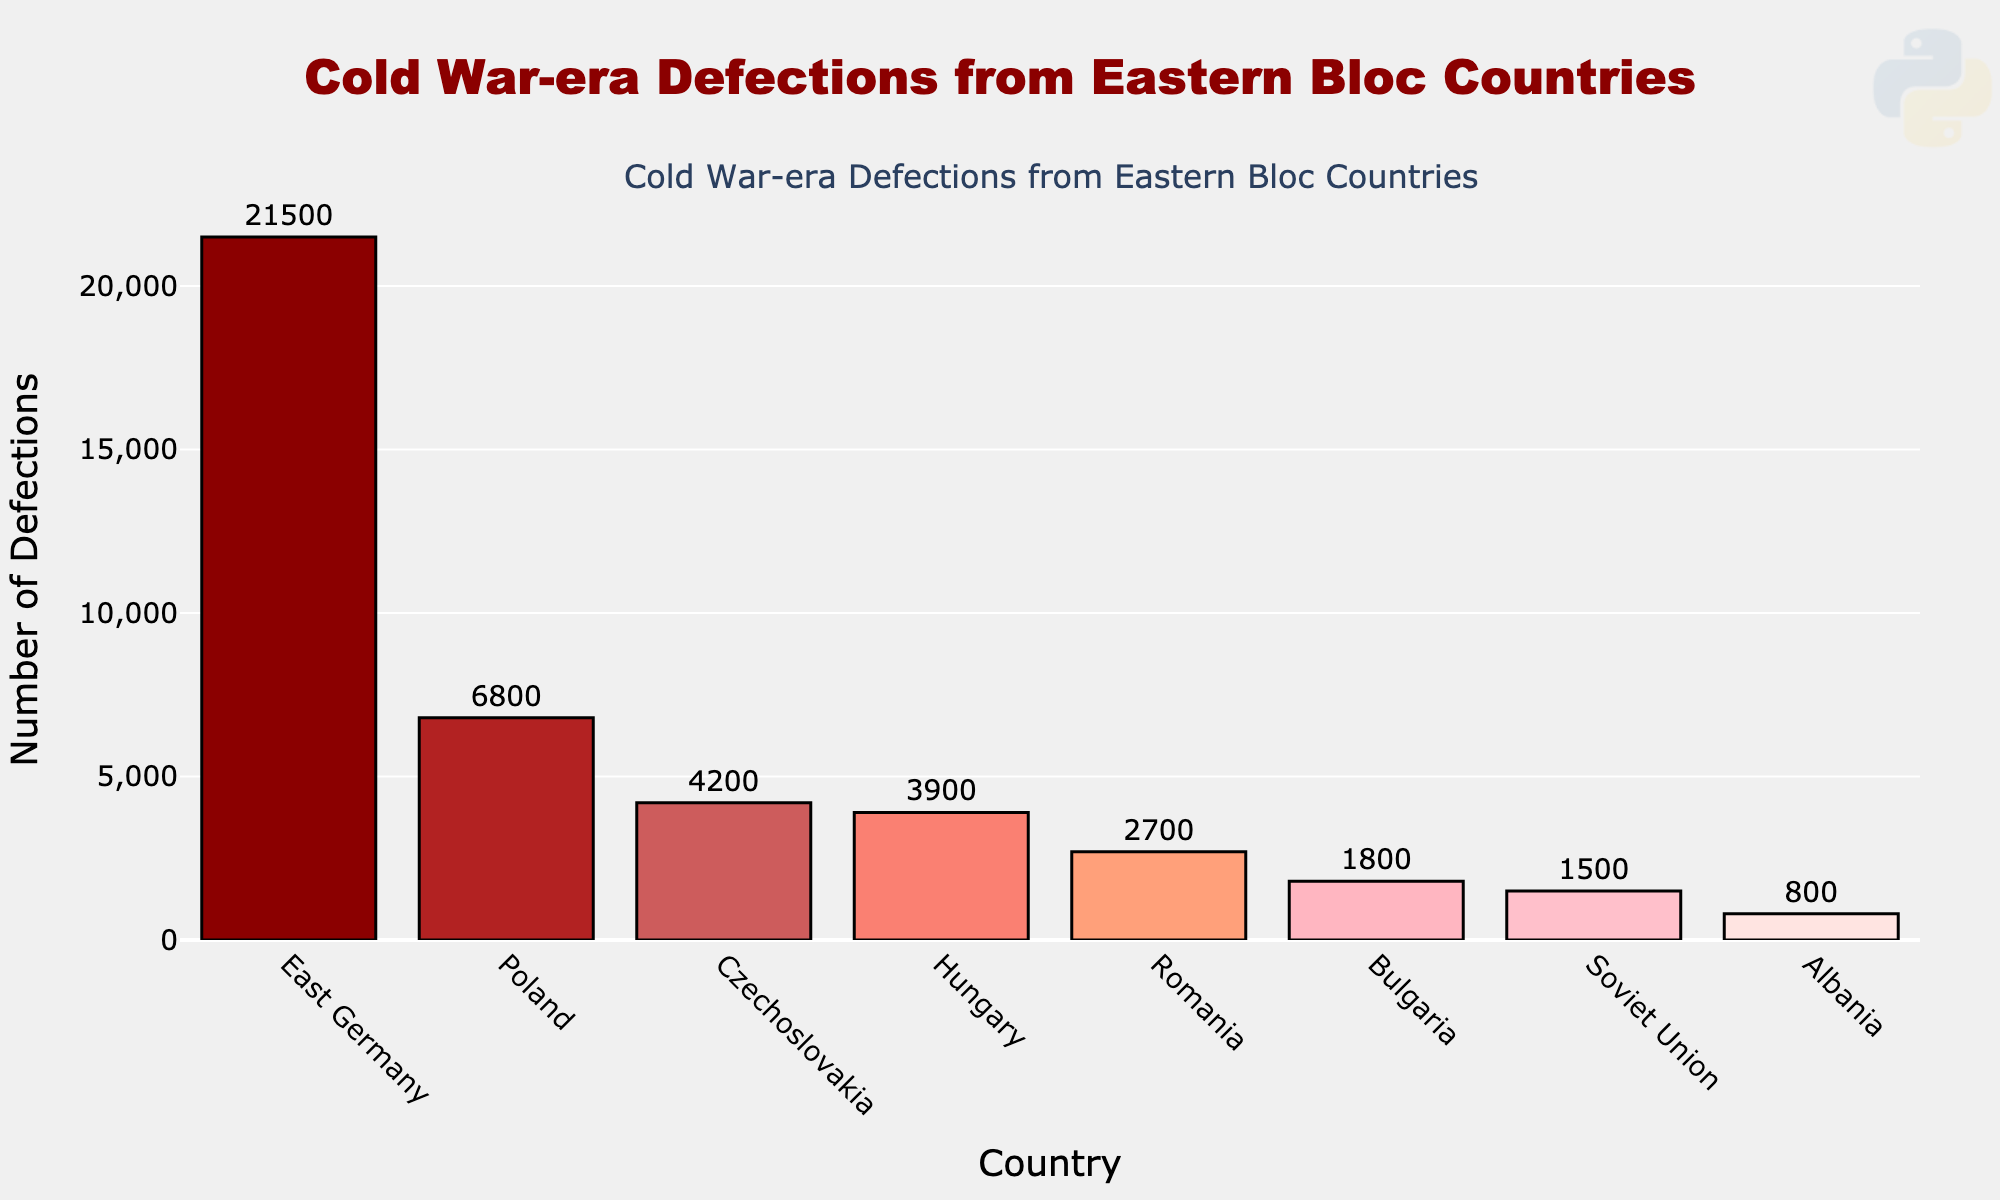How many more defections were there from East Germany compared to the Soviet Union? To determine the difference, subtract the number of Soviet Union defections from those of East Germany. East Germany had 21,500 defections and the Soviet Union had 1,500 defections. So, the difference is 21,500 - 1,500 = 20,000.
Answer: 20,000 Which country had the lowest number of defections? From the figure, we can see that Albania had the lowest bar among all the countries. The number of defections for Albania is 800, which is the smallest value on the chart.
Answer: Albania Rank the countries by the number of defections in descending order. The countries should be listed from the highest to the lowest number based on the bar heights shown on the chart. The order is: East Germany, Poland, Czechoslovakia, Hungary, Romania, Bulgaria, Soviet Union, and Albania.
Answer: East Germany, Poland, Czechoslovakia, Hungary, Romania, Bulgaria, Soviet Union, Albania What is the total number of defections from all Eastern Bloc countries combined? To find the total number of defections, sum all the values: 21,500 (East Germany) + 6,800 (Poland) + 4,200 (Czechoslovakia) + 3,900 (Hungary) + 2,700 (Romania) + 1,800 (Bulgaria) + 1,500 (Soviet Union) + 800 (Albania) = 43,200.
Answer: 43,200 Which two countries have the closest number of defections and what is the difference? By comparing the values visually, Hungary and Czechoslovakia have close numbers, with 3,900 and 4,200 defections respectively. The difference is 4,200 - 3,900 = 300.
Answer: Hungary and Czechoslovakia, 300 What is the sum of defections for the countries with the three smallest numbers? The three countries with the smallest defections are Albania (800), Soviet Union (1,500), and Bulgaria (1,800). So the sum is 800 + 1,500 + 1,800 = 4,100.
Answer: 4,100 What is the average number of defections per country? To find the average, divide the total number of defections by the number of countries. The total number of defections is 43,200, and there are 8 countries. The average is 43,200 / 8 = 5,400.
Answer: 5,400 Which country stands out with a significantly higher number of defections based on the bar height? The country that stands out visually with the highest bar is East Germany, which had 21,500 defections, a significantly higher number compared to the others.
Answer: East Germany What is the difference between the number of defections from Romania and Bulgaria? To find the difference, subtract the number of defections from Bulgaria from that of Romania: 2,700 (Romania) - 1,800 (Bulgaria) = 900.
Answer: 900 